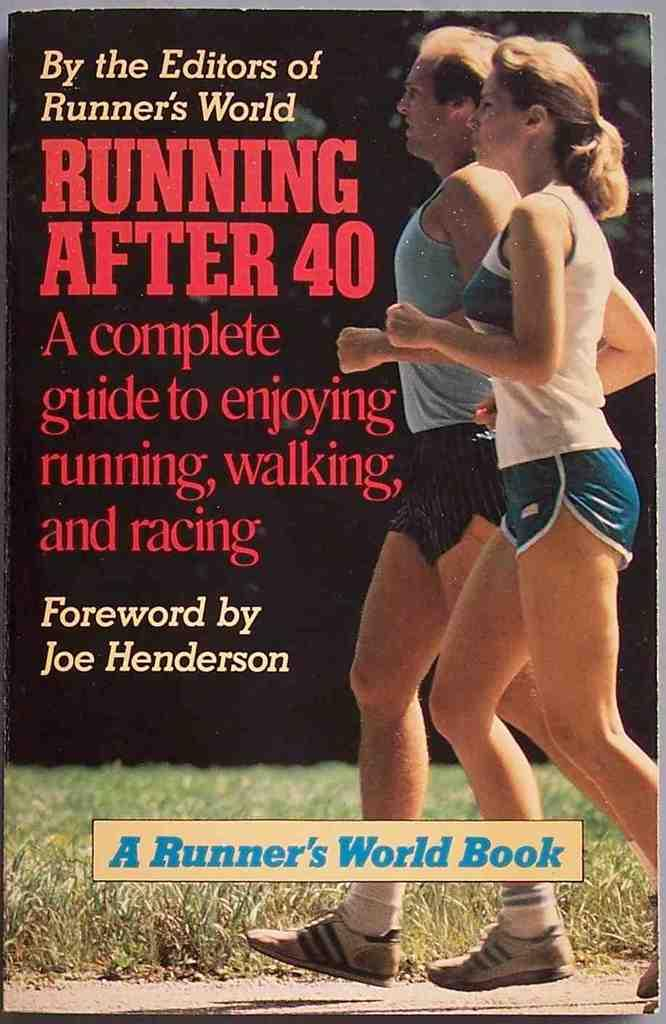<image>
Share a concise interpretation of the image provided. Book cover which says "A Runner's World Book" on the bottom. 